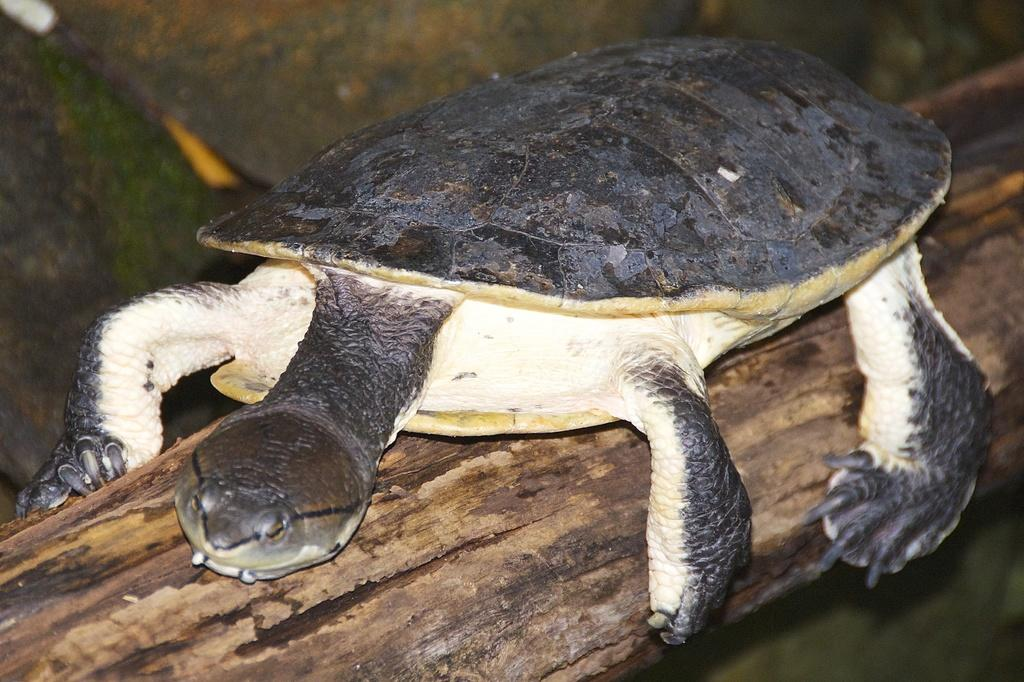What is the main subject in the center of the image? There is a tortoise in the center of the image. What is the tortoise resting on? The tortoise is on a log. What can be seen in the background of the image? There is greenery in the background of the image. Is there a carpenter working on a swing in the image? No, there is no carpenter or swing present in the image. Can you see a bat flying in the background of the image? No, there is no bat visible in the image; only greenery can be seen in the background. 